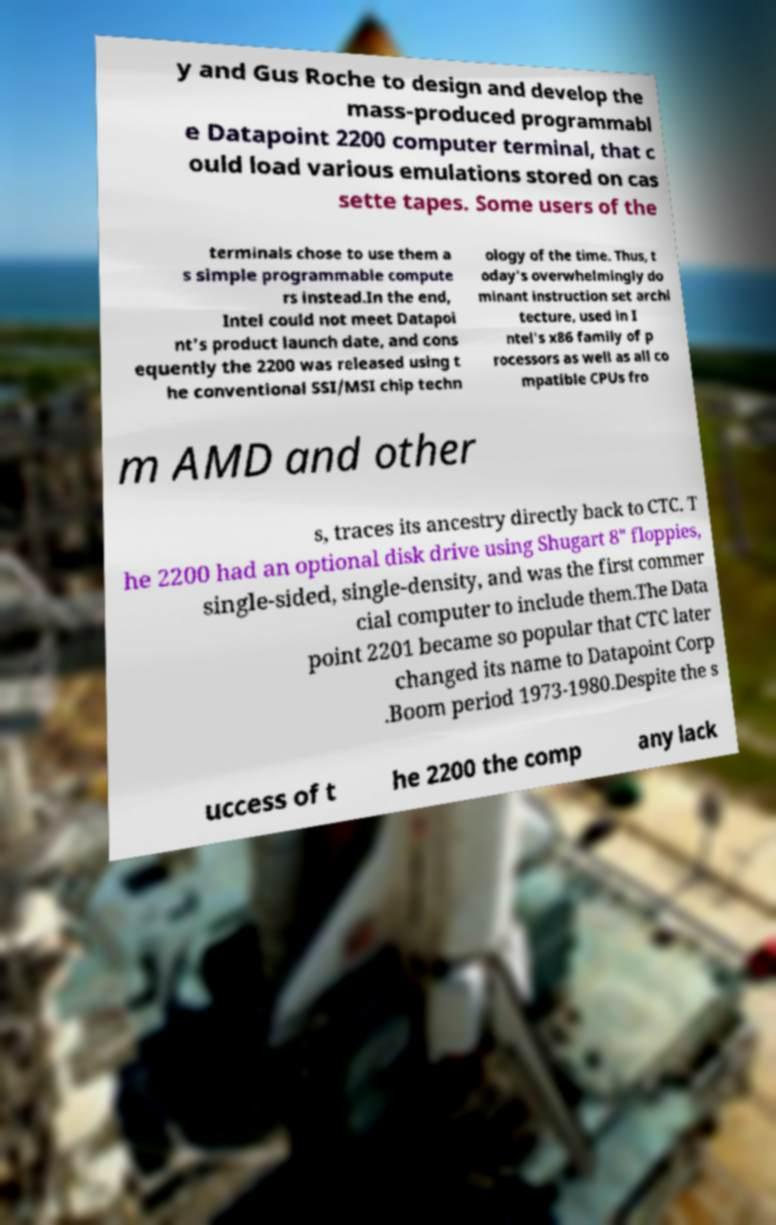Please identify and transcribe the text found in this image. y and Gus Roche to design and develop the mass-produced programmabl e Datapoint 2200 computer terminal, that c ould load various emulations stored on cas sette tapes. Some users of the terminals chose to use them a s simple programmable compute rs instead.In the end, Intel could not meet Datapoi nt's product launch date, and cons equently the 2200 was released using t he conventional SSI/MSI chip techn ology of the time. Thus, t oday's overwhelmingly do minant instruction set archi tecture, used in I ntel's x86 family of p rocessors as well as all co mpatible CPUs fro m AMD and other s, traces its ancestry directly back to CTC. T he 2200 had an optional disk drive using Shugart 8" floppies, single-sided, single-density, and was the first commer cial computer to include them.The Data point 2201 became so popular that CTC later changed its name to Datapoint Corp .Boom period 1973-1980.Despite the s uccess of t he 2200 the comp any lack 